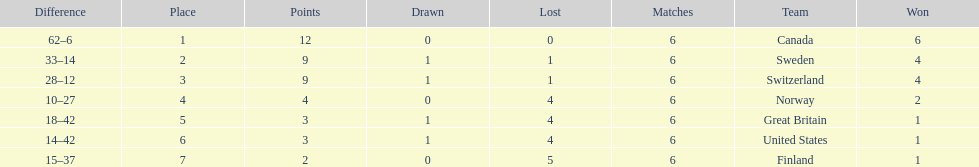Which country performed better during the 1951 world ice hockey championships, switzerland or great britain? Switzerland. 